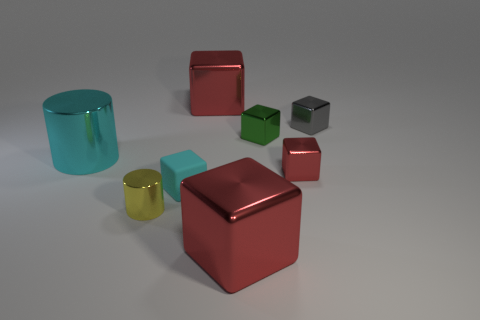Is there any other thing that has the same material as the small cyan cube?
Provide a short and direct response. No. The metal cylinder that is the same size as the cyan cube is what color?
Provide a short and direct response. Yellow. What material is the yellow thing that is in front of the green object?
Provide a succinct answer. Metal. There is a big red metal object in front of the tiny cyan thing; is its shape the same as the small red object to the right of the rubber cube?
Provide a succinct answer. Yes. Are there the same number of cyan rubber objects that are left of the small yellow object and purple matte cylinders?
Make the answer very short. Yes. What number of small cyan cubes have the same material as the tiny gray object?
Give a very brief answer. 0. What is the color of the big cylinder that is made of the same material as the small gray cube?
Offer a terse response. Cyan. Is the size of the cyan block the same as the red block behind the large cylinder?
Your answer should be compact. No. The small rubber object is what shape?
Give a very brief answer. Cube. How many shiny cylinders are the same color as the tiny rubber cube?
Provide a succinct answer. 1. 